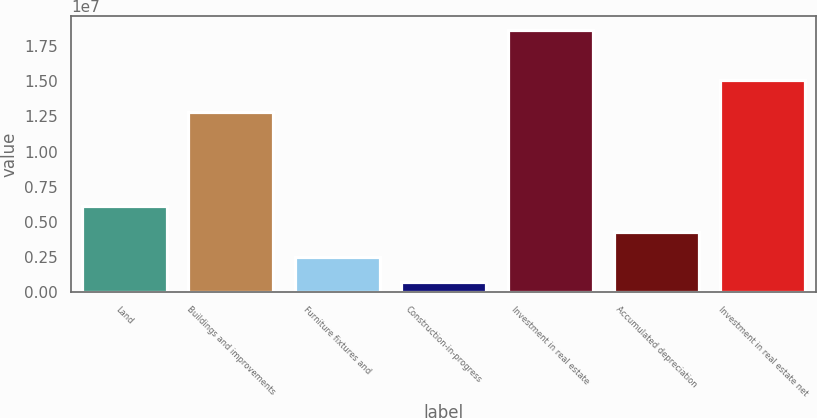Convert chart. <chart><loc_0><loc_0><loc_500><loc_500><bar_chart><fcel>Land<fcel>Buildings and improvements<fcel>Furniture fixtures and<fcel>Construction-in-progress<fcel>Investment in real estate<fcel>Accumulated depreciation<fcel>Investment in real estate net<nl><fcel>6.08315e+06<fcel>1.28363e+07<fcel>2.48113e+06<fcel>680118<fcel>1.86902e+07<fcel>4.28214e+06<fcel>1.51289e+07<nl></chart> 